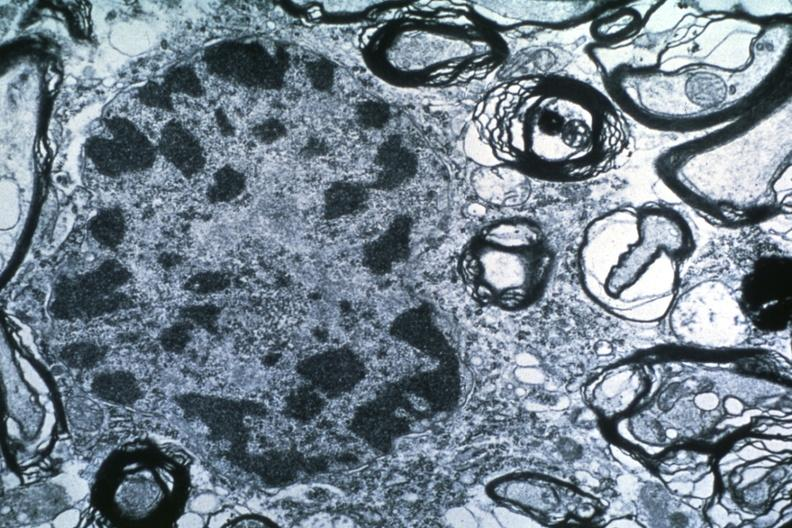s follicular fibrosis suggesting previous viral infection present?
Answer the question using a single word or phrase. No 